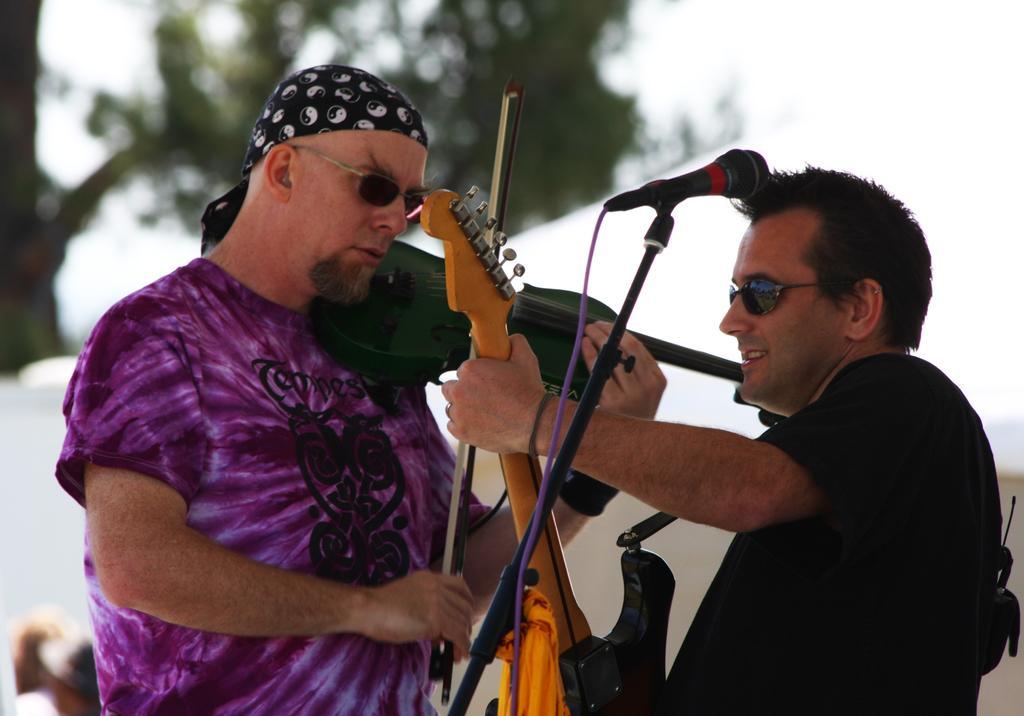Can you describe this image briefly? In this image there are two men standing. The picture looks like it is clicked outside. To the right the man is wearing black color t-shirt, and holding a guitar. To the left the man is wearing purple color t-shirt and holding a violin. In the middle there is a mic along with mic stand. In the background, there is a tree and sky. 